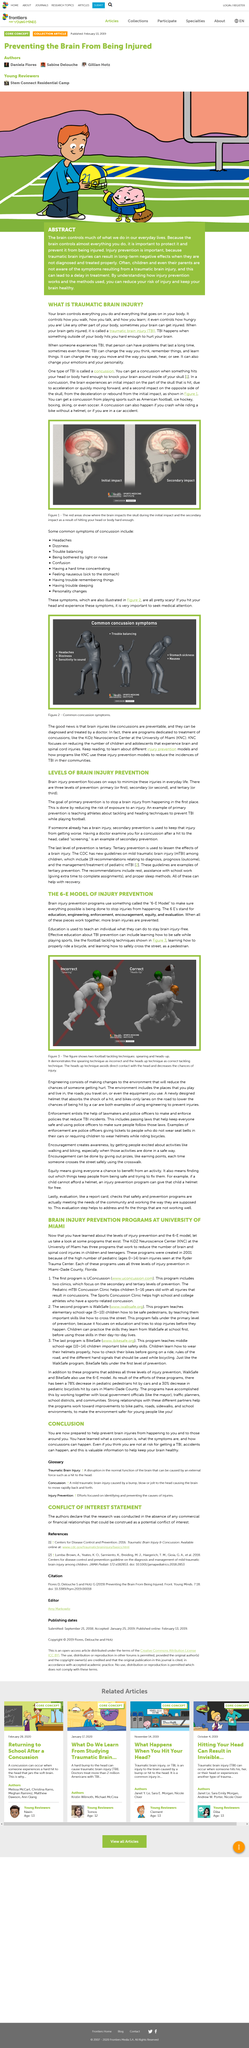Outline some significant characteristics in this image. The use of the heads up technique in football is the correct method, as it ensures the most effective tackling strategy. The second brain injury prevention program is called WalkSafe. The following are common symptoms of concussion: headaches, dizziness, trouble balancing, being bothered by light or noise, confusion, having a hard time concentrating, feeling nauseous, having trouble remembering things, having trouble sleeping and personality changes. In 2001, brain injury prevention programs were established to promote safe living practices and reduce the incidence of brain injuries. Two examples of footballing tackling techniques are spearing and heads-up tackling. Spearing involves striking an opponent below the knee with the helmet, while heads-up tackling prioritizes using the shoulder and helmet to tackle an opponent while keeping the head up and eyes on the ball. 